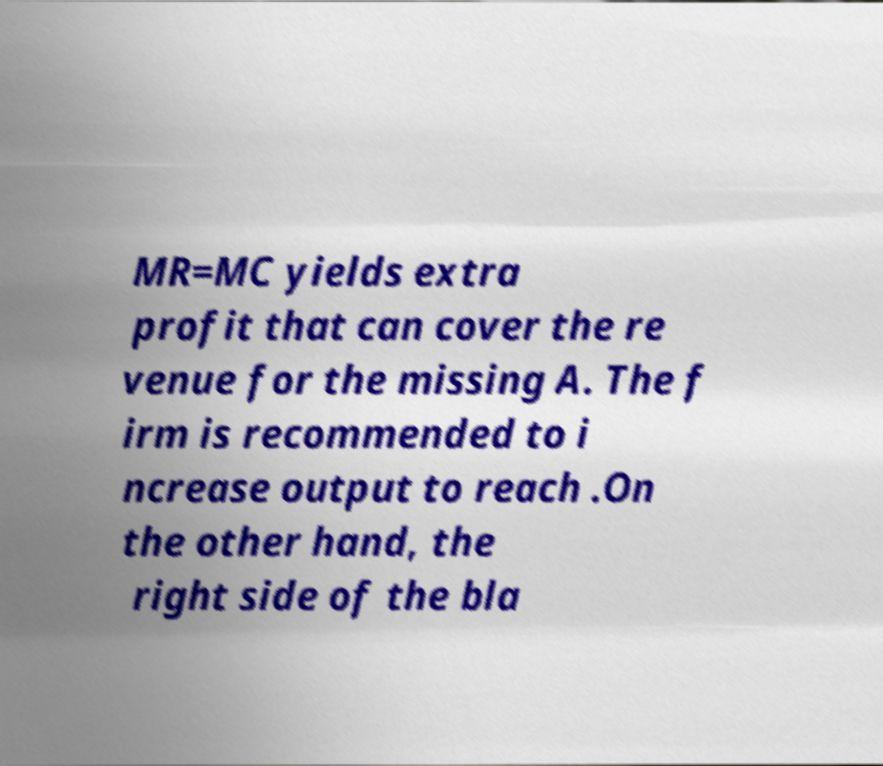Could you extract and type out the text from this image? MR=MC yields extra profit that can cover the re venue for the missing A. The f irm is recommended to i ncrease output to reach .On the other hand, the right side of the bla 